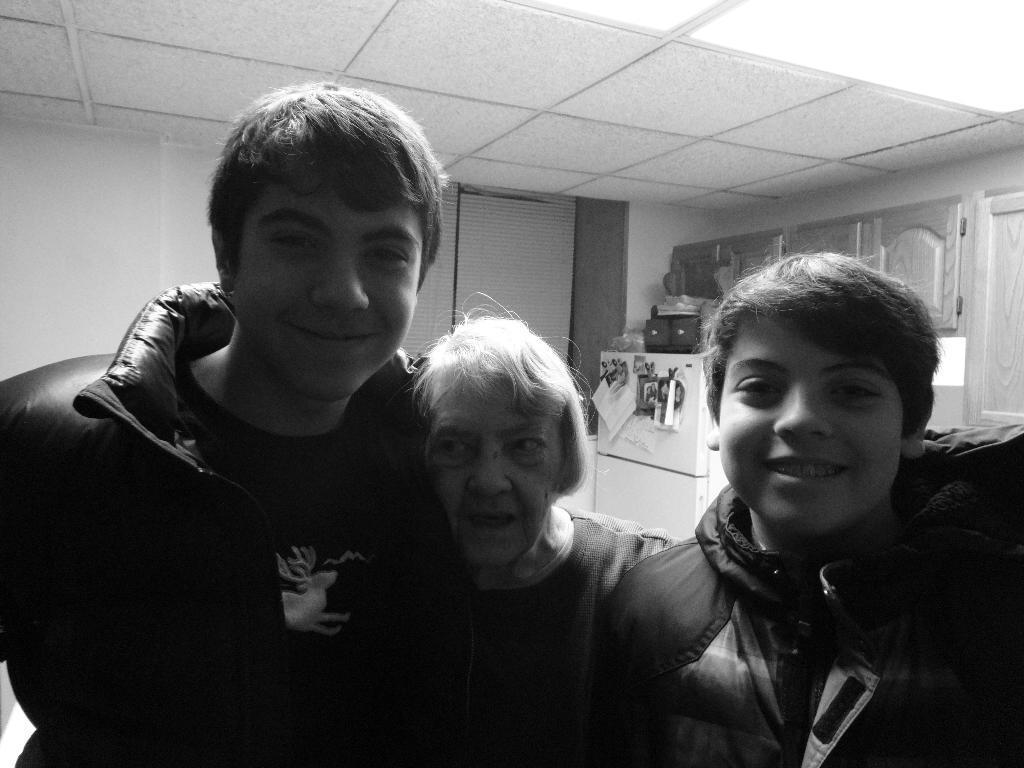Describe this image in one or two sentences. It is a black and white image there are three people standing in the front and posing for the photo, behind them there is a refrigerator and some cupboards. 